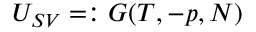Convert formula to latex. <formula><loc_0><loc_0><loc_500><loc_500>U _ { S V } = \colon G ( T , - p , N )</formula> 